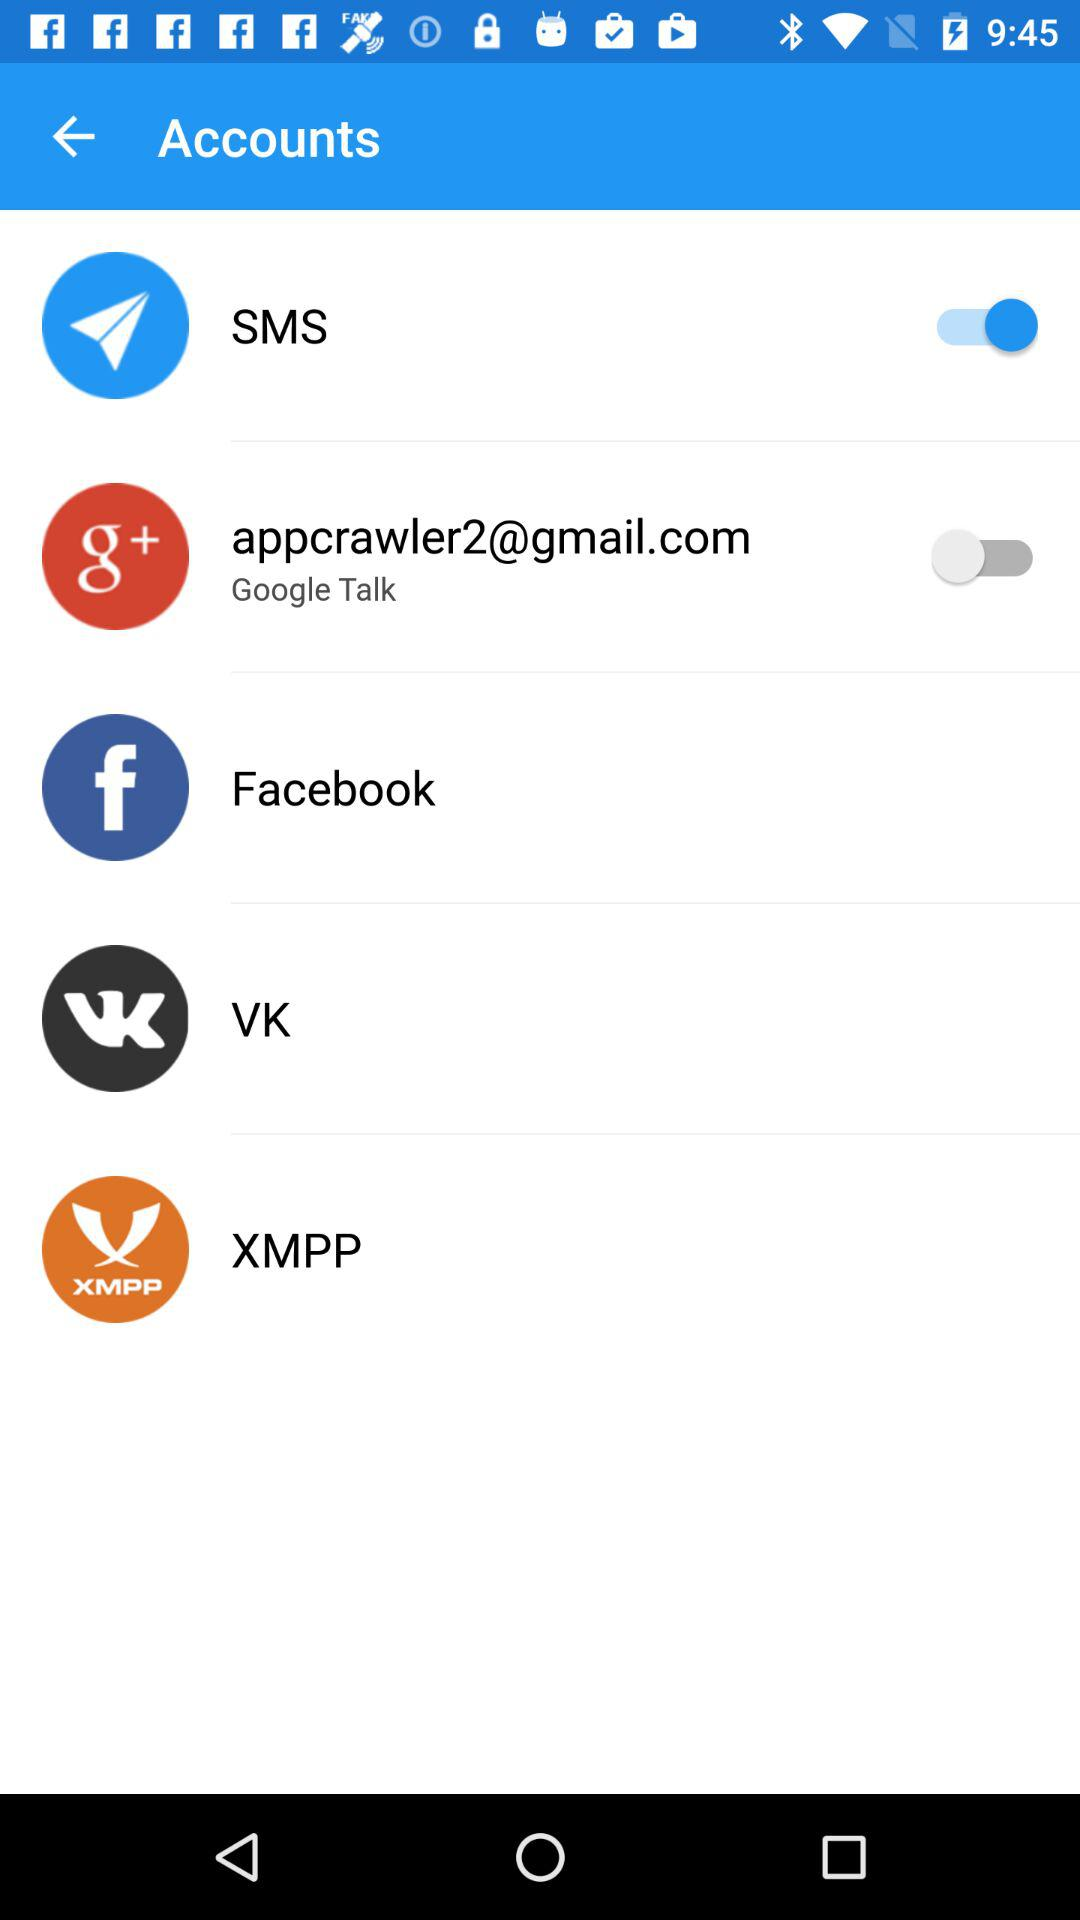What is the status of "Google Talk". The status is "off". 